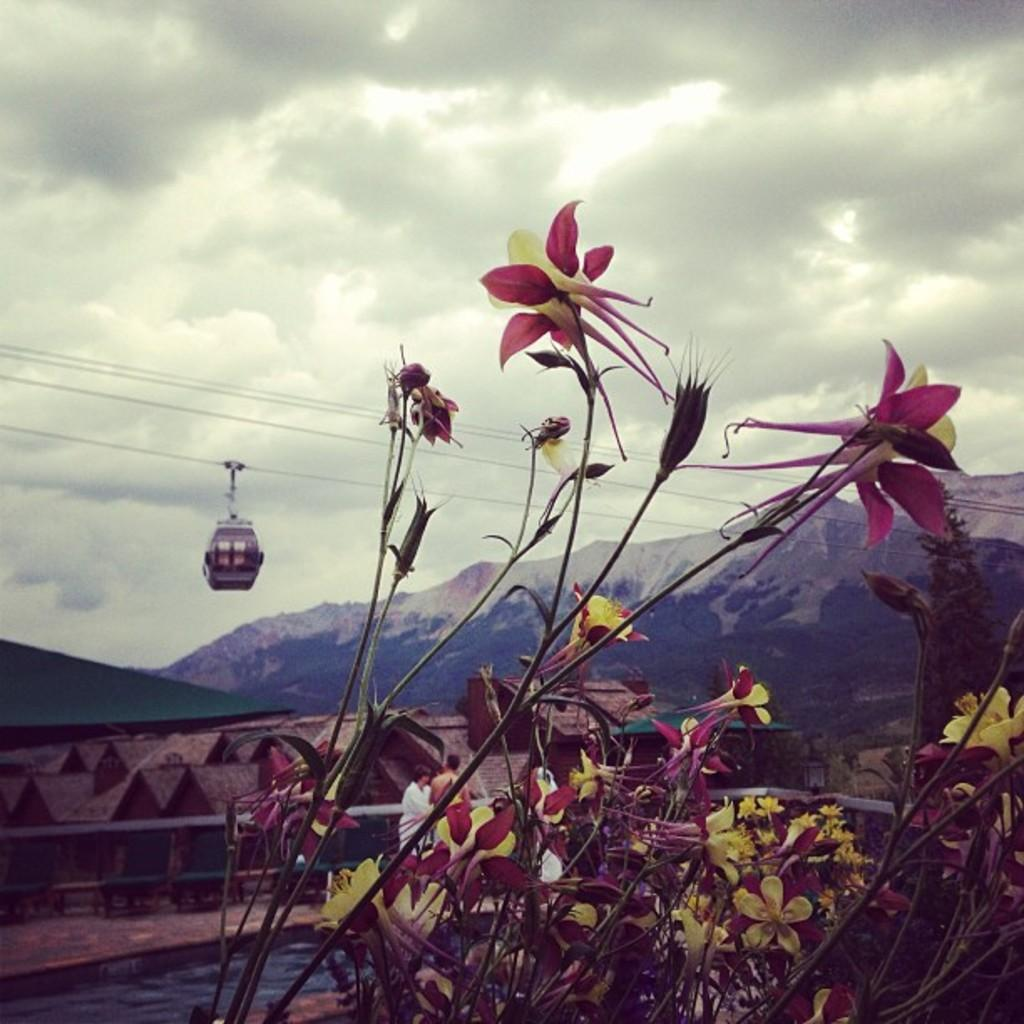What is located in the foreground of the image? There are flowers in the foreground of the image. What can be seen in the background of the image? There is a cable car, a wall, sea, mountains, and a cloudy sky visible in the background of the image. What type of transportation is present in the image? There is a cable car in the background of the image. What natural features are visible in the background of the image? Mountains and sea are visible in the background of the image. Can you tell me how many goose feathers are on the trail in the image? There is no trail or goose feathers present in the image. What level of difficulty is the beginner trail in the image? There is no trail or mention of a beginner level in the image. 